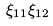Convert formula to latex. <formula><loc_0><loc_0><loc_500><loc_500>\xi _ { 1 1 } & \xi _ { 1 2 } \\</formula> 